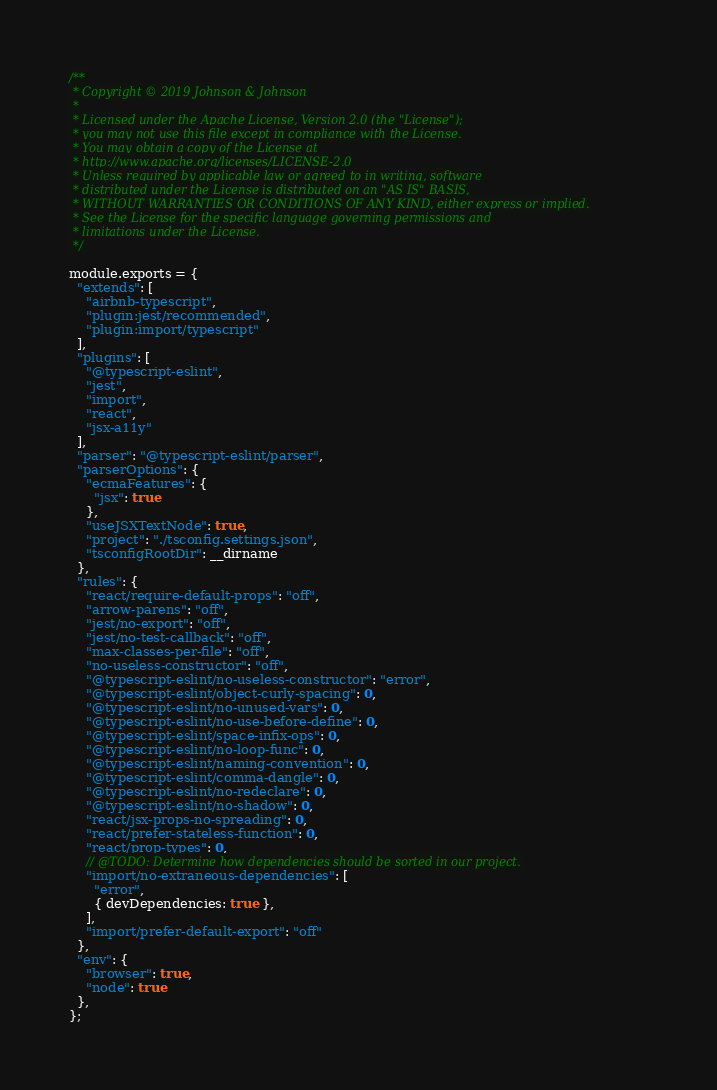Convert code to text. <code><loc_0><loc_0><loc_500><loc_500><_JavaScript_>/**
 * Copyright © 2019 Johnson & Johnson
 *
 * Licensed under the Apache License, Version 2.0 (the "License");
 * you may not use this file except in compliance with the License.
 * You may obtain a copy of the License at
 * http://www.apache.org/licenses/LICENSE-2.0
 * Unless required by applicable law or agreed to in writing, software
 * distributed under the License is distributed on an "AS IS" BASIS,
 * WITHOUT WARRANTIES OR CONDITIONS OF ANY KIND, either express or implied.
 * See the License for the specific language governing permissions and
 * limitations under the License.
 */

module.exports = {
  "extends": [
    "airbnb-typescript",
    "plugin:jest/recommended",
    "plugin:import/typescript"
  ],
  "plugins": [
    "@typescript-eslint",
    "jest",
    "import",
    "react",
    "jsx-a11y"
  ],
  "parser": "@typescript-eslint/parser",
  "parserOptions": {
    "ecmaFeatures": {
      "jsx": true
    },
    "useJSXTextNode": true,
    "project": "./tsconfig.settings.json",
    "tsconfigRootDir": __dirname
  },
  "rules": {
    "react/require-default-props": "off",
    "arrow-parens": "off",
    "jest/no-export": "off",
    "jest/no-test-callback": "off",
    "max-classes-per-file": "off",
    "no-useless-constructor": "off",
    "@typescript-eslint/no-useless-constructor": "error",
    "@typescript-eslint/object-curly-spacing": 0,
    "@typescript-eslint/no-unused-vars": 0,
    "@typescript-eslint/no-use-before-define": 0,
    "@typescript-eslint/space-infix-ops": 0,
    "@typescript-eslint/no-loop-func": 0,
    "@typescript-eslint/naming-convention": 0,
    "@typescript-eslint/comma-dangle": 0,
    "@typescript-eslint/no-redeclare": 0,
    "@typescript-eslint/no-shadow": 0,
    "react/jsx-props-no-spreading": 0,
    "react/prefer-stateless-function": 0,
    "react/prop-types": 0,
    // @TODO: Determine how dependencies should be sorted in our project.
    "import/no-extraneous-dependencies": [
      "error",
      { devDependencies: true },
    ],
    "import/prefer-default-export": "off"
  },
  "env": {
    "browser": true,
    "node": true
  },
};

</code> 